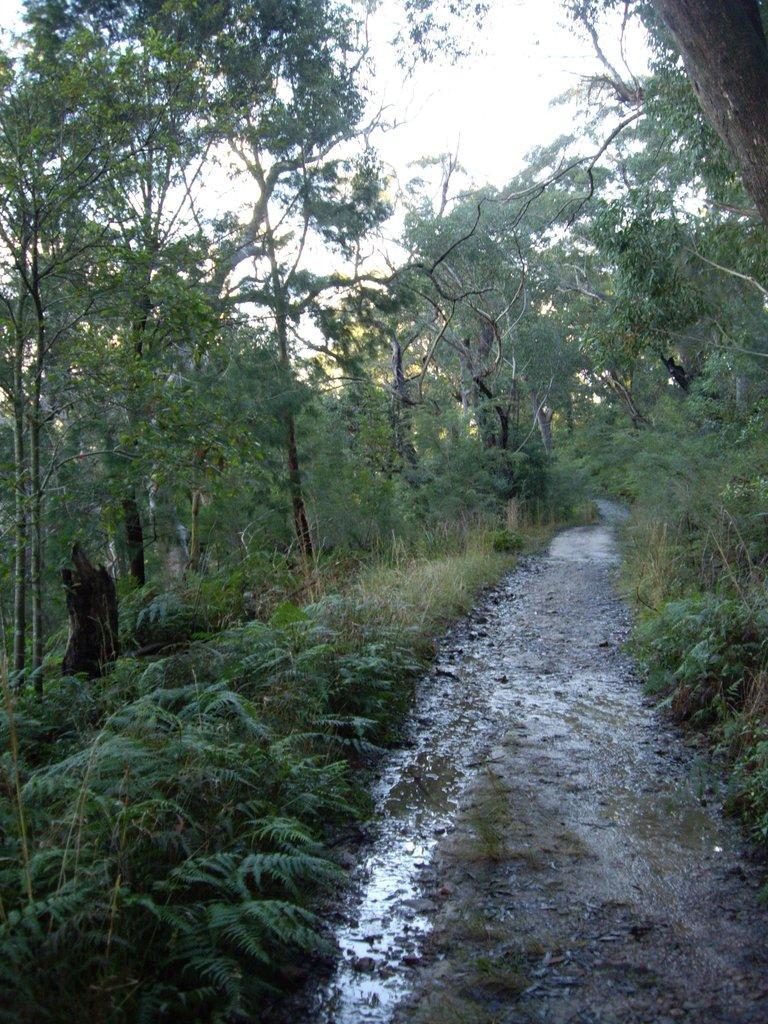How would you summarize this image in a sentence or two? In the picture there is a lot of greenery, there is a small walkway in between the grass and it is wet and there is a slight moisture on the walkway. 